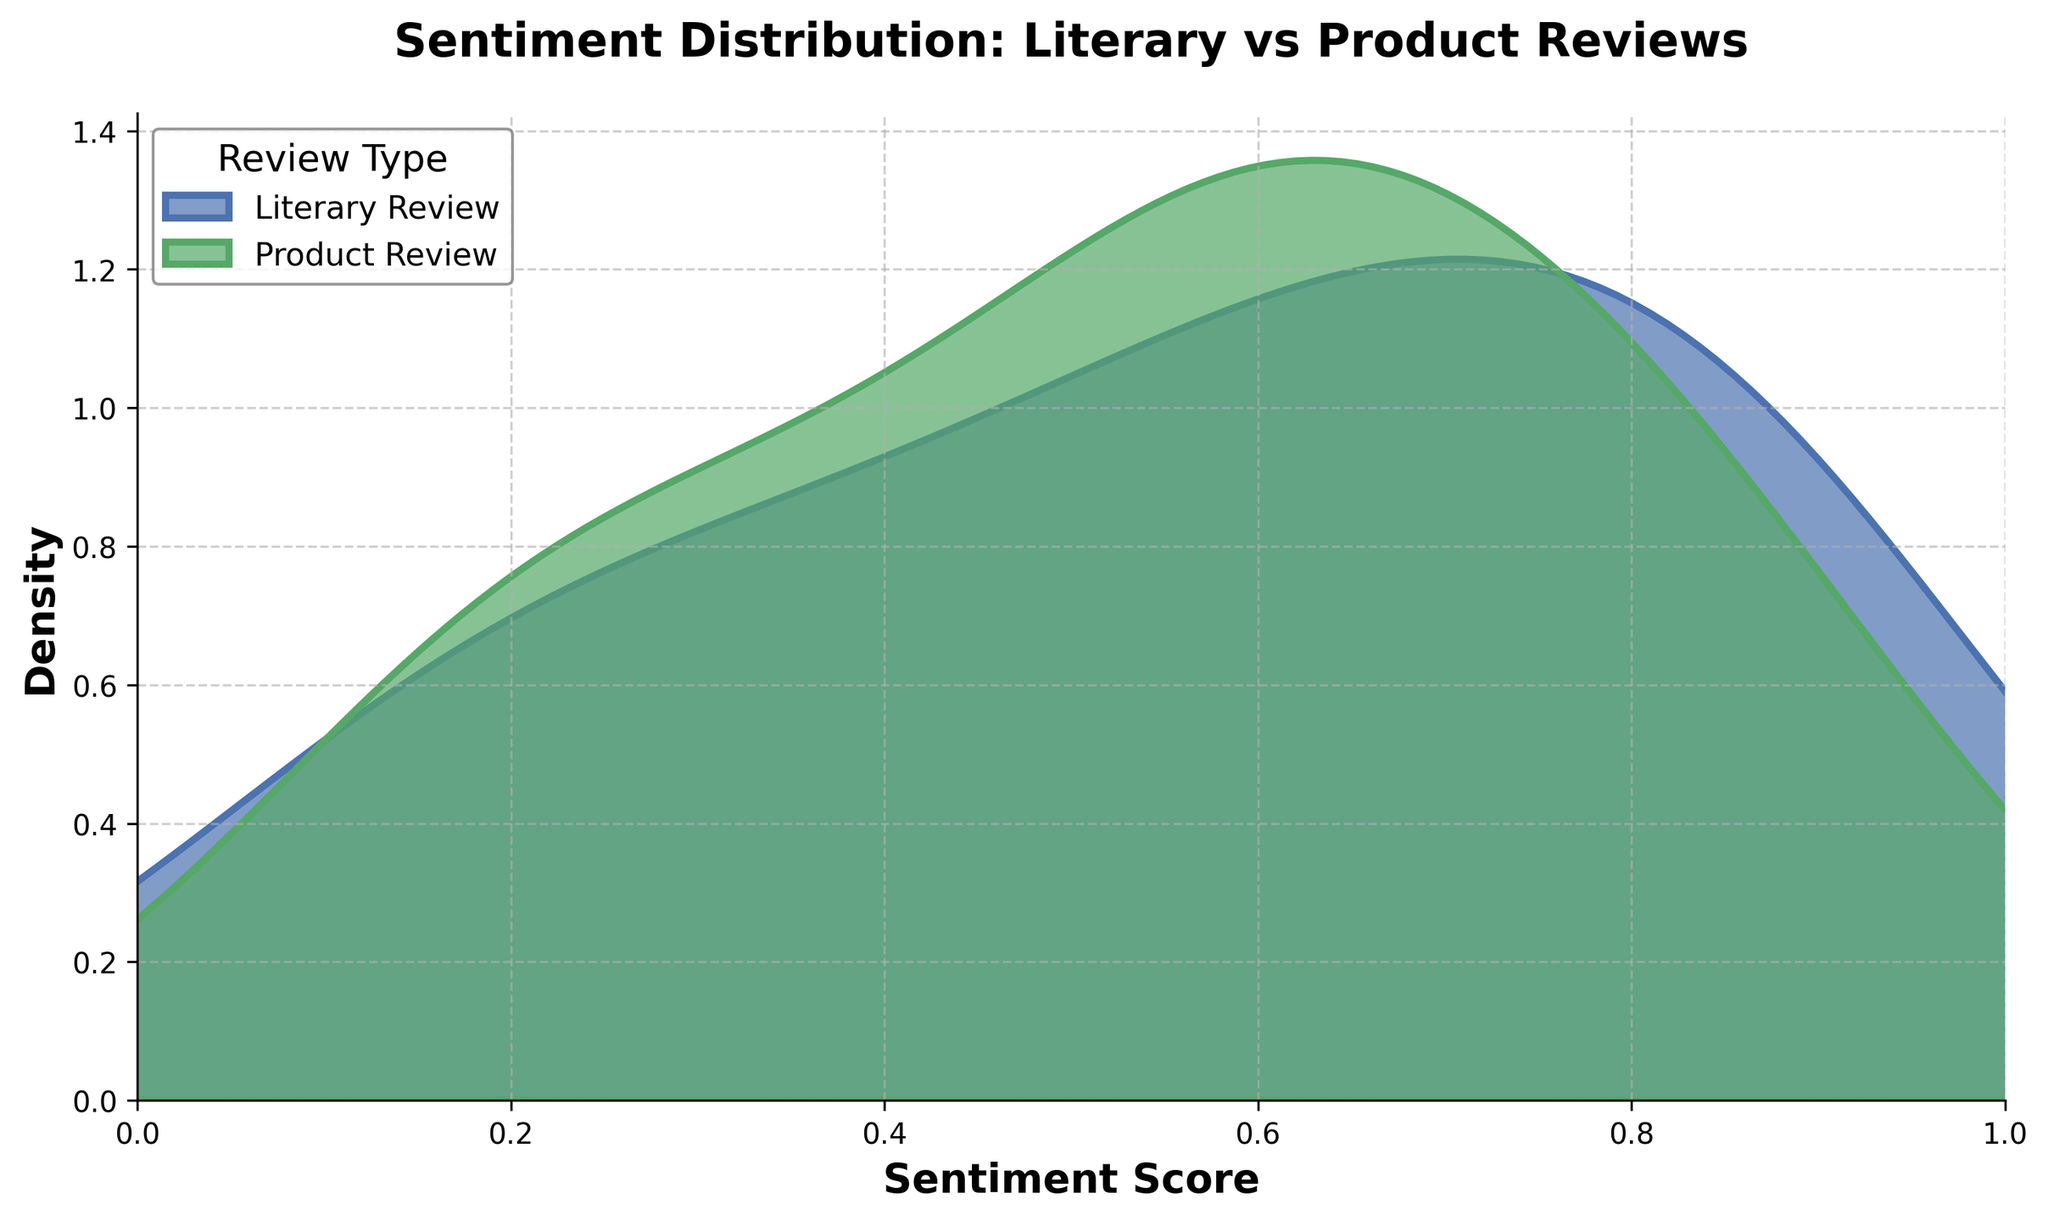What is the x-axis labeled as? The x-axis is labeled as "Sentiment Score," which indicates the range of sentiment values plotted in the density plot.
Answer: Sentiment Score What is the range of sentiment scores displayed on the plot? The x-axis of the plot ranges from 0 to 1, representing the sentiment scores between these values.
Answer: 0 to 1 Which review type shows a higher peak density? By observing the plot, we can see that the "Literary Review" has a higher peak density compared to "Product Review."
Answer: Literary Review What does the shaded area represent in the plot? The shaded area under each curve represents the density of sentiment scores for that particular review type.
Answer: Density of sentiment scores Are there any sentiment scores that are common to both review types? By noting the overlap of the density curves along the x-axis, we see that both review types exhibit sentiment scores across the range of 0 to 1, indicating their commonality.
Answer: Yes Which review type shows a more varied range of sentiment scores? Although both types cover the same range, "Product Reviews" show significant density throughout the entire range indicating a more varied distribution, while "Literary Reviews" peaks more significantly around certain values.
Answer: Product Review Is there a sentiment score where product reviews show noticeably higher density than literary reviews? Product reviews show noticeably higher density around the sentiment score of 0.7 compared to literary reviews.
Answer: 0.7 What is the title of the plot? The title of the plot is "Sentiment Distribution: Literary vs Product Reviews."
Answer: Sentiment Distribution: Literary vs Product Reviews How many curves are depicted in the plot? There are two curves in the plot, representing "Literary Review" and "Product Review."
Answer: Two Is there a sentiment score where literary reviews have a noticeable peak? The "Literary Review" curve shows noticeable peaks around the sentiment scores of 0.3 and 0.8.
Answer: 0.3 and 0.8 